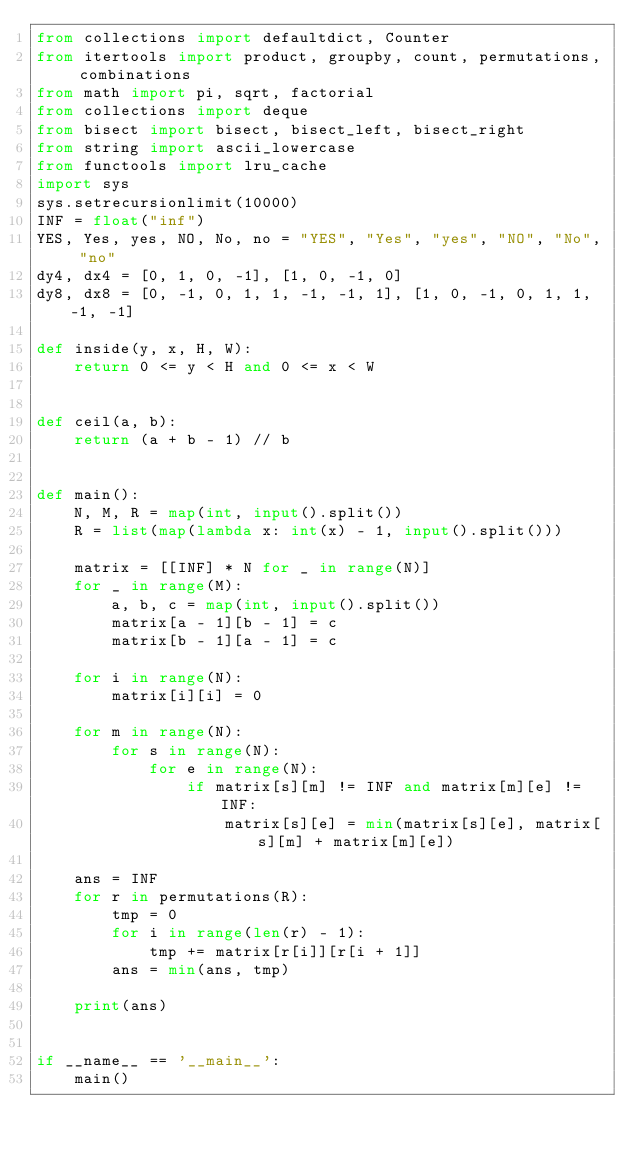<code> <loc_0><loc_0><loc_500><loc_500><_Python_>from collections import defaultdict, Counter
from itertools import product, groupby, count, permutations, combinations
from math import pi, sqrt, factorial
from collections import deque
from bisect import bisect, bisect_left, bisect_right
from string import ascii_lowercase
from functools import lru_cache
import sys
sys.setrecursionlimit(10000)
INF = float("inf")
YES, Yes, yes, NO, No, no = "YES", "Yes", "yes", "NO", "No", "no"
dy4, dx4 = [0, 1, 0, -1], [1, 0, -1, 0]
dy8, dx8 = [0, -1, 0, 1, 1, -1, -1, 1], [1, 0, -1, 0, 1, 1, -1, -1]

def inside(y, x, H, W):
    return 0 <= y < H and 0 <= x < W


def ceil(a, b):
    return (a + b - 1) // b


def main():
    N, M, R = map(int, input().split())
    R = list(map(lambda x: int(x) - 1, input().split()))

    matrix = [[INF] * N for _ in range(N)]
    for _ in range(M):
        a, b, c = map(int, input().split())
        matrix[a - 1][b - 1] = c
        matrix[b - 1][a - 1] = c

    for i in range(N):
        matrix[i][i] = 0

    for m in range(N):
        for s in range(N):
            for e in range(N):
                if matrix[s][m] != INF and matrix[m][e] != INF:
                    matrix[s][e] = min(matrix[s][e], matrix[s][m] + matrix[m][e])

    ans = INF
    for r in permutations(R):
        tmp = 0
        for i in range(len(r) - 1):
            tmp += matrix[r[i]][r[i + 1]]
        ans = min(ans, tmp)

    print(ans)


if __name__ == '__main__':
    main()
</code> 